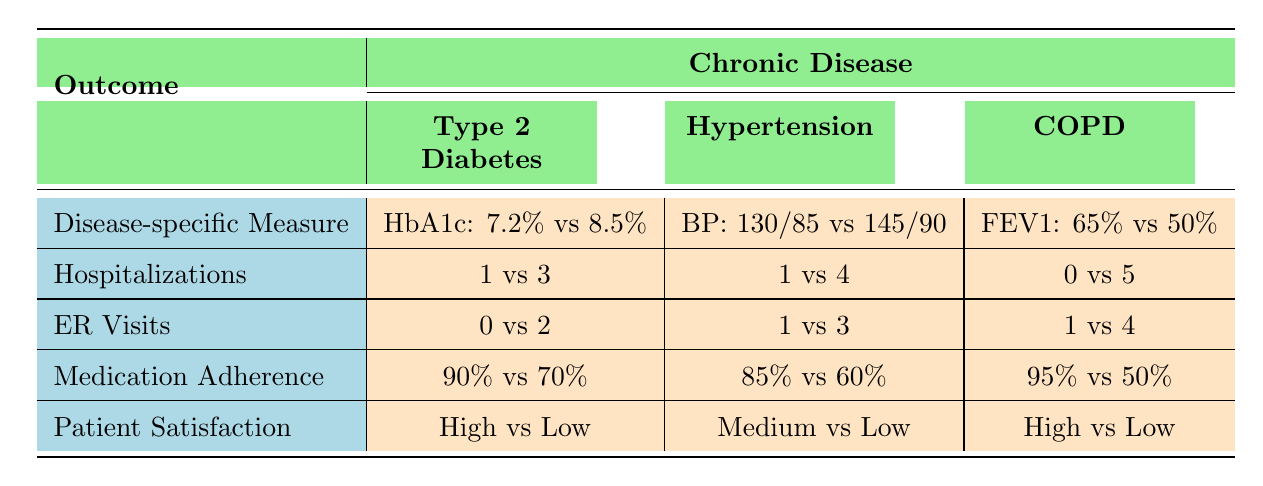What is the HbA1c level for vaccinated patients with Type 2 Diabetes? The table shows that for vaccinated patients with Type 2 Diabetes, the HbA1c level is 7.2%. This is directly noted under the disease-specific measure for Type 2 Diabetes where the vaccinated status is indicated.
Answer: 7.2% How many hospitalizations did non-vaccinated patients with COPD experience? According to the table, non-vaccinated COPD patients had 5 hospitalizations. This value is found under the hospitalizations row for chronic obstructive pulmonary disease when the vaccination status is false.
Answer: 5 What is the difference in medication adherence between vaccinated and non-vaccinated Hypertension patients? The vaccinated patients had a medication adherence of 85%, while non-vaccinated had 60%. The difference can be calculated as 85% - 60% = 25%. This computation is based on the values shown in the medication adherence row for Hypertension.
Answer: 25% Did vaccinated patients with any chronic disease have a higher patient satisfaction than their non-vaccinated counterparts? Reviewing the patient satisfaction data, vaccinated patients with Type 2 Diabetes and COPD had "High" satisfaction, while the non-vaccinated counterparts showed "Low" satisfaction. For Hypertension, vaccinated patients reported "Medium" while non-vaccinated had "Low". Therefore, vaccinated patients had higher satisfaction in all cases, leading to a "Yes".
Answer: Yes What is the average hospitalizations for vaccinated patients across all chronic diseases? From the table, vaccinated patients had hospitalizations of 1 (Type 2 Diabetes), 1 (Hypertension), and 0 (COPD). Adding these gives total hospitalizations of 2 across 3 diseases, therefore the average is 2/3 = 0.67 when summarized.
Answer: 0.67 